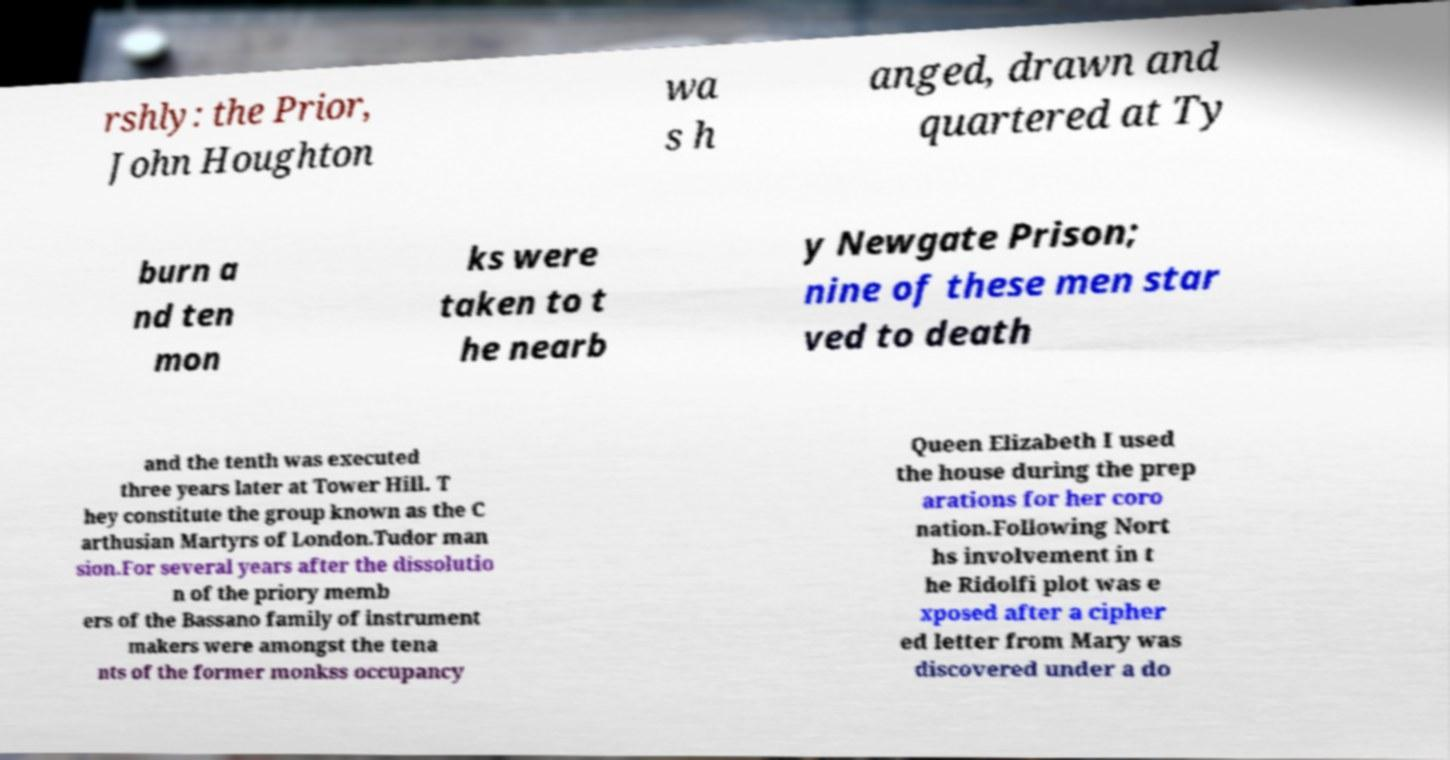Please identify and transcribe the text found in this image. rshly: the Prior, John Houghton wa s h anged, drawn and quartered at Ty burn a nd ten mon ks were taken to t he nearb y Newgate Prison; nine of these men star ved to death and the tenth was executed three years later at Tower Hill. T hey constitute the group known as the C arthusian Martyrs of London.Tudor man sion.For several years after the dissolutio n of the priory memb ers of the Bassano family of instrument makers were amongst the tena nts of the former monkss occupancy Queen Elizabeth I used the house during the prep arations for her coro nation.Following Nort hs involvement in t he Ridolfi plot was e xposed after a cipher ed letter from Mary was discovered under a do 